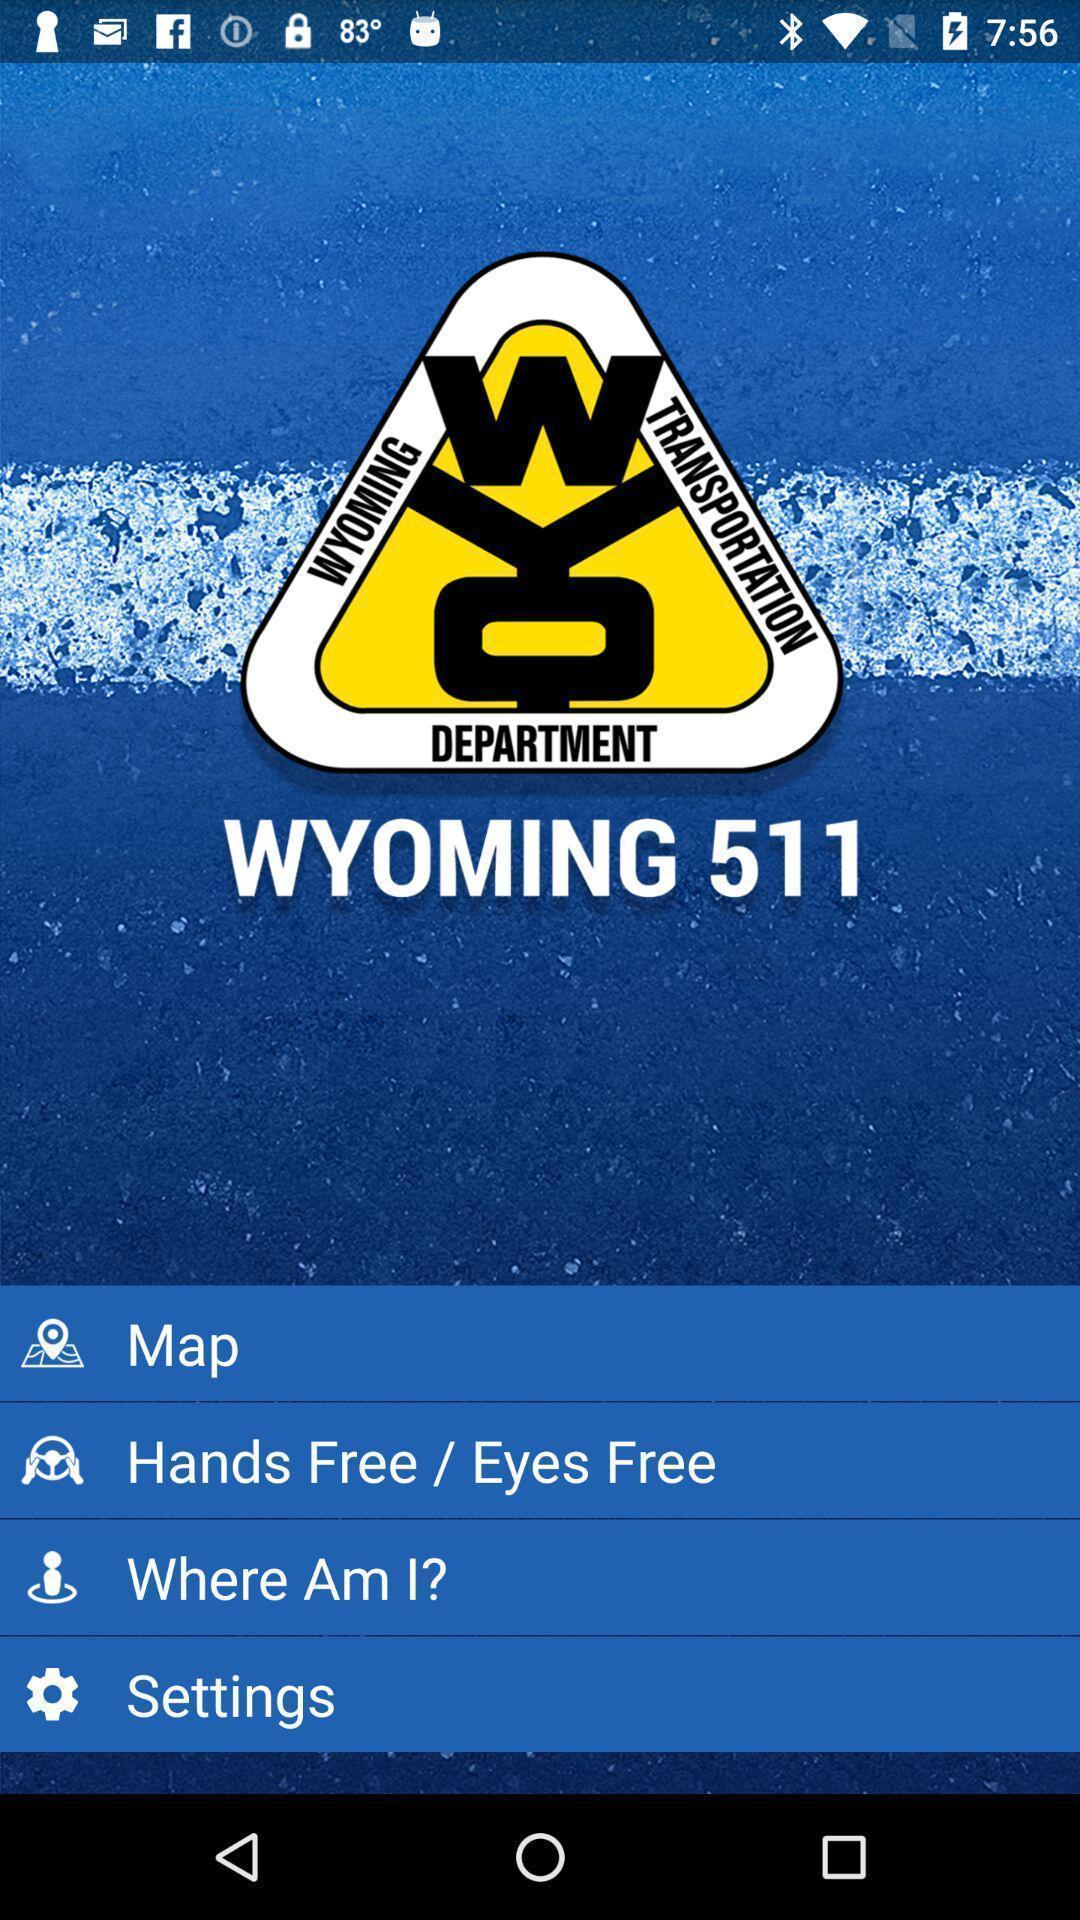Please provide a description for this image. Welcome page of a traffic monitoring app. 